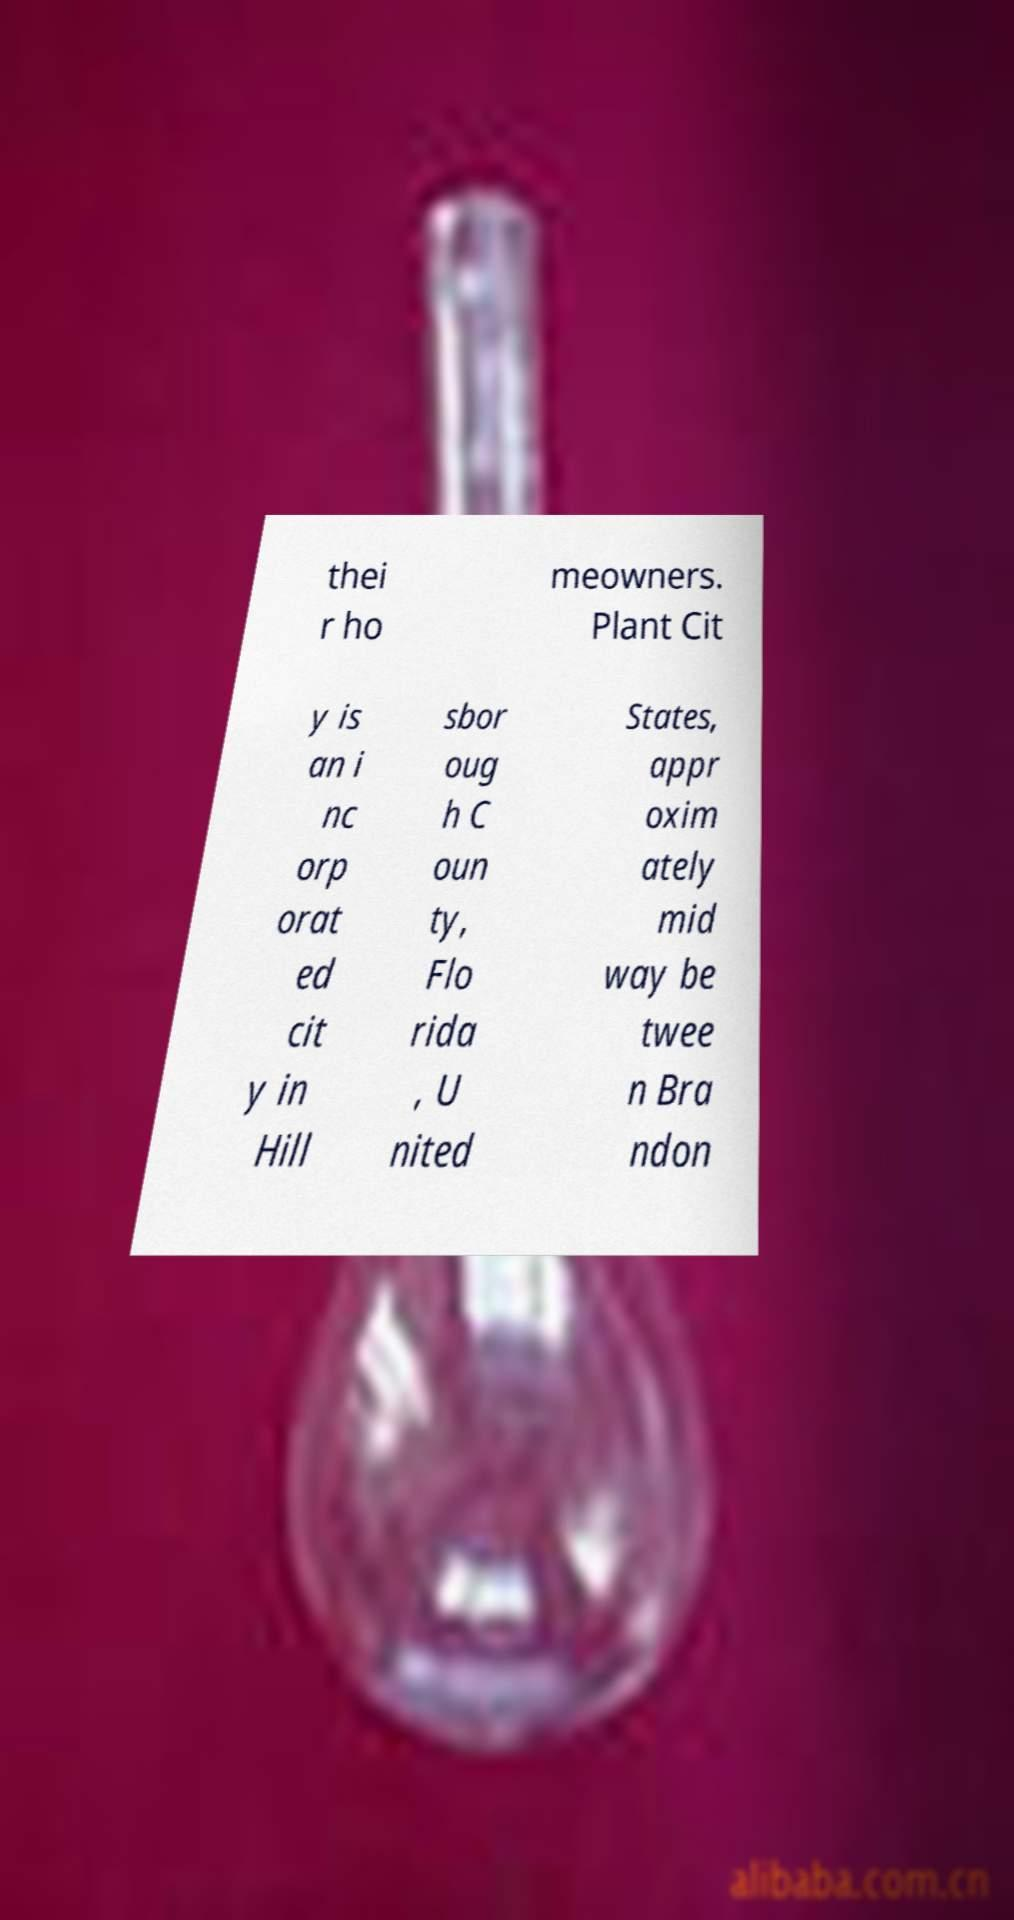I need the written content from this picture converted into text. Can you do that? thei r ho meowners. Plant Cit y is an i nc orp orat ed cit y in Hill sbor oug h C oun ty, Flo rida , U nited States, appr oxim ately mid way be twee n Bra ndon 